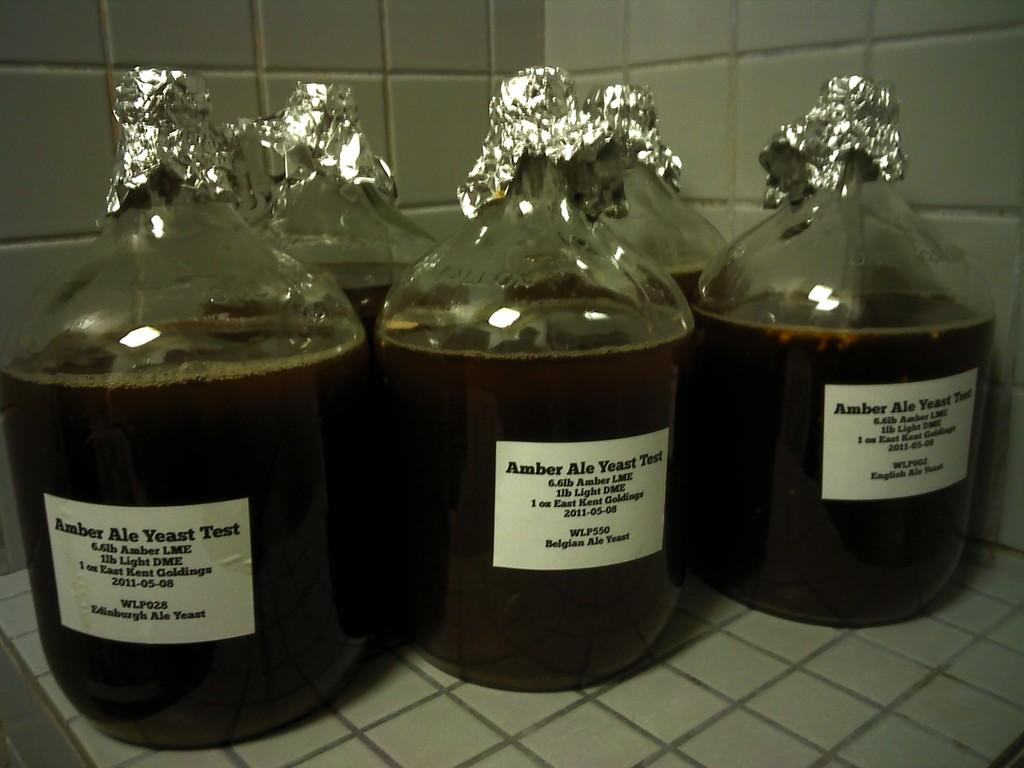<image>
Present a compact description of the photo's key features. Three jugs of liquid with an "Amber Ale Yeast Test" sign on them. 